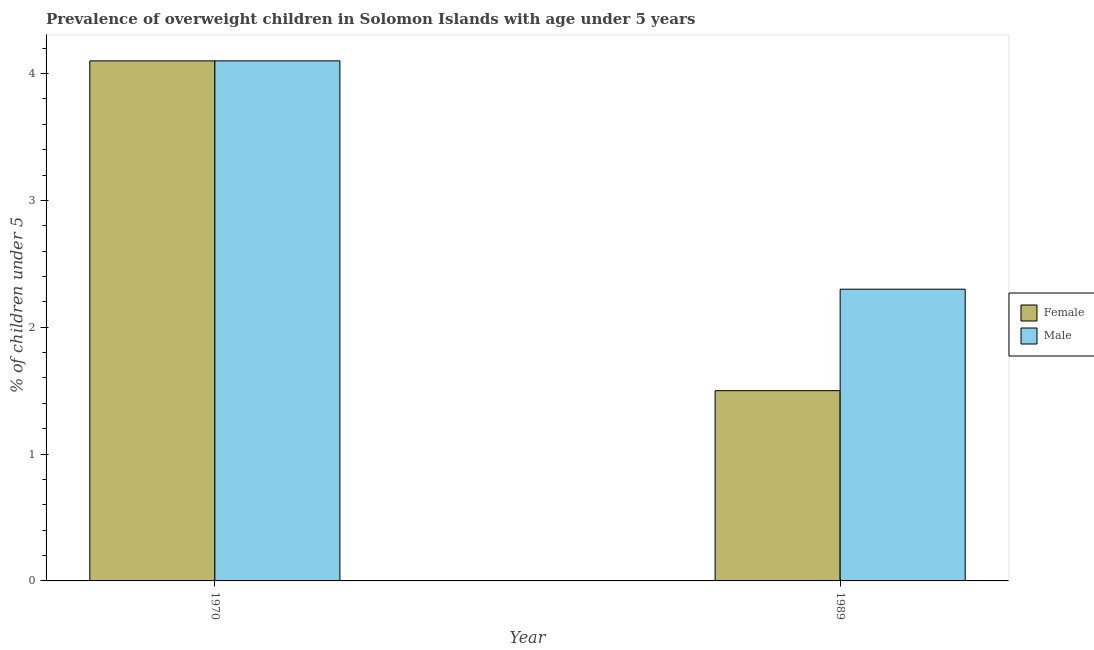How many different coloured bars are there?
Offer a terse response. 2. Are the number of bars on each tick of the X-axis equal?
Your response must be concise. Yes. How many bars are there on the 1st tick from the left?
Provide a short and direct response. 2. What is the label of the 2nd group of bars from the left?
Ensure brevity in your answer.  1989. In how many cases, is the number of bars for a given year not equal to the number of legend labels?
Your answer should be very brief. 0. What is the percentage of obese female children in 1970?
Ensure brevity in your answer.  4.1. Across all years, what is the maximum percentage of obese male children?
Your answer should be compact. 4.1. Across all years, what is the minimum percentage of obese male children?
Provide a short and direct response. 2.3. In which year was the percentage of obese male children minimum?
Offer a very short reply. 1989. What is the total percentage of obese female children in the graph?
Your response must be concise. 5.6. What is the difference between the percentage of obese female children in 1970 and that in 1989?
Your response must be concise. 2.6. What is the difference between the percentage of obese female children in 1989 and the percentage of obese male children in 1970?
Provide a succinct answer. -2.6. What is the average percentage of obese male children per year?
Ensure brevity in your answer.  3.2. In the year 1970, what is the difference between the percentage of obese female children and percentage of obese male children?
Your response must be concise. 0. What is the ratio of the percentage of obese male children in 1970 to that in 1989?
Your response must be concise. 1.78. In how many years, is the percentage of obese male children greater than the average percentage of obese male children taken over all years?
Offer a very short reply. 1. What does the 2nd bar from the left in 1970 represents?
Give a very brief answer. Male. What does the 2nd bar from the right in 1989 represents?
Your answer should be very brief. Female. How many bars are there?
Offer a very short reply. 4. Are all the bars in the graph horizontal?
Provide a short and direct response. No. What is the difference between two consecutive major ticks on the Y-axis?
Provide a short and direct response. 1. Are the values on the major ticks of Y-axis written in scientific E-notation?
Give a very brief answer. No. Does the graph contain any zero values?
Give a very brief answer. No. Does the graph contain grids?
Keep it short and to the point. No. What is the title of the graph?
Make the answer very short. Prevalence of overweight children in Solomon Islands with age under 5 years. Does "Agricultural land" appear as one of the legend labels in the graph?
Your answer should be compact. No. What is the label or title of the Y-axis?
Provide a succinct answer.  % of children under 5. What is the  % of children under 5 of Female in 1970?
Your answer should be compact. 4.1. What is the  % of children under 5 in Male in 1970?
Offer a terse response. 4.1. What is the  % of children under 5 of Male in 1989?
Offer a terse response. 2.3. Across all years, what is the maximum  % of children under 5 in Female?
Your answer should be very brief. 4.1. Across all years, what is the maximum  % of children under 5 in Male?
Provide a succinct answer. 4.1. Across all years, what is the minimum  % of children under 5 in Male?
Provide a succinct answer. 2.3. What is the total  % of children under 5 in Male in the graph?
Keep it short and to the point. 6.4. What is the difference between the  % of children under 5 of Female in 1970 and that in 1989?
Your answer should be compact. 2.6. What is the average  % of children under 5 of Female per year?
Provide a succinct answer. 2.8. What is the average  % of children under 5 of Male per year?
Your answer should be very brief. 3.2. In the year 1970, what is the difference between the  % of children under 5 in Female and  % of children under 5 in Male?
Your answer should be very brief. 0. In the year 1989, what is the difference between the  % of children under 5 in Female and  % of children under 5 in Male?
Offer a terse response. -0.8. What is the ratio of the  % of children under 5 in Female in 1970 to that in 1989?
Your response must be concise. 2.73. What is the ratio of the  % of children under 5 of Male in 1970 to that in 1989?
Provide a succinct answer. 1.78. What is the difference between the highest and the lowest  % of children under 5 of Male?
Offer a very short reply. 1.8. 